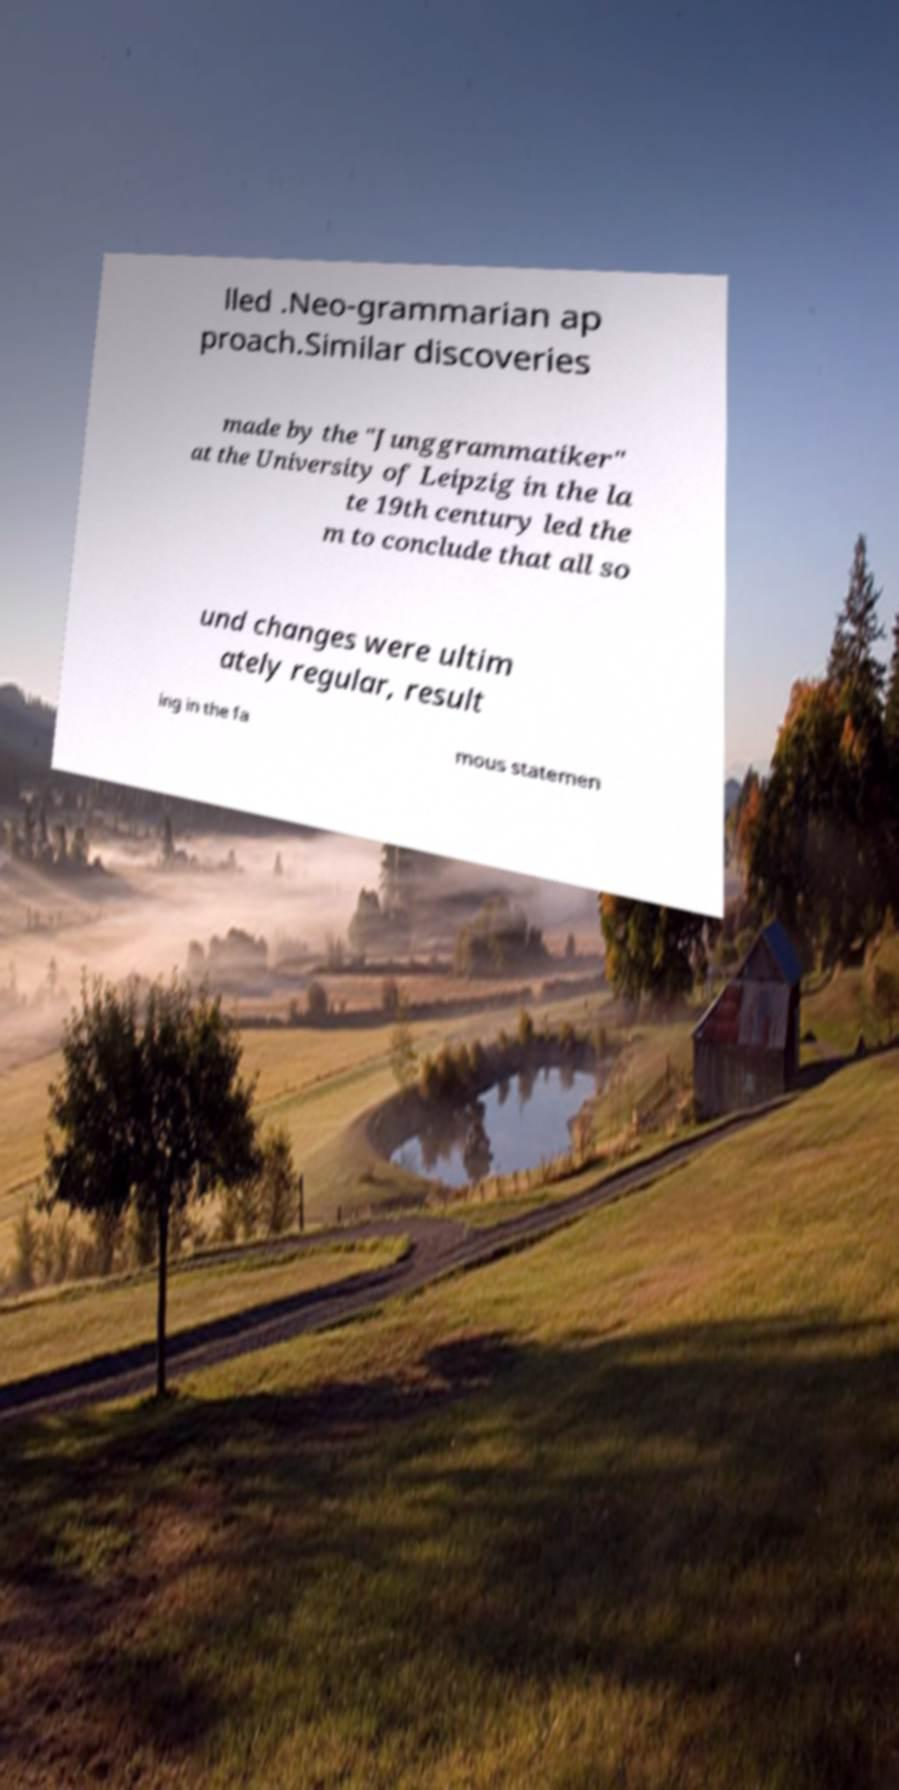Could you assist in decoding the text presented in this image and type it out clearly? lled .Neo-grammarian ap proach.Similar discoveries made by the "Junggrammatiker" at the University of Leipzig in the la te 19th century led the m to conclude that all so und changes were ultim ately regular, result ing in the fa mous statemen 